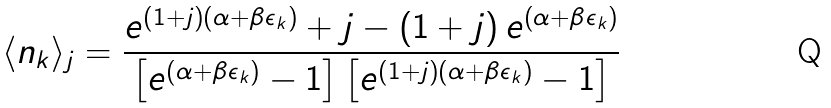Convert formula to latex. <formula><loc_0><loc_0><loc_500><loc_500>\langle n _ { k } \rangle _ { j } = \frac { e ^ { \left ( 1 + j \right ) \left ( \alpha + \beta \epsilon _ { k } \right ) } + j - \left ( 1 + j \right ) e ^ { \left ( \alpha + \beta \epsilon _ { k } \right ) } } { \left [ e ^ { \left ( \alpha + \beta \epsilon _ { k } \right ) } - 1 \right ] \left [ e ^ { \left ( 1 + j \right ) \left ( \alpha + \beta \epsilon _ { k } \right ) } - 1 \right ] }</formula> 